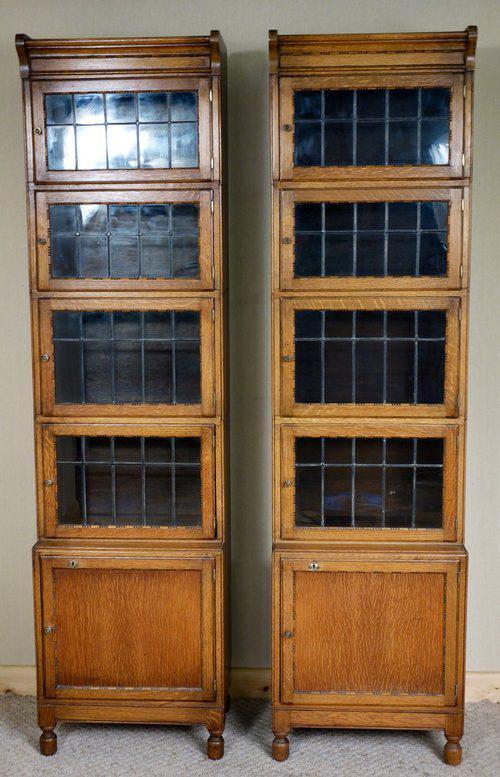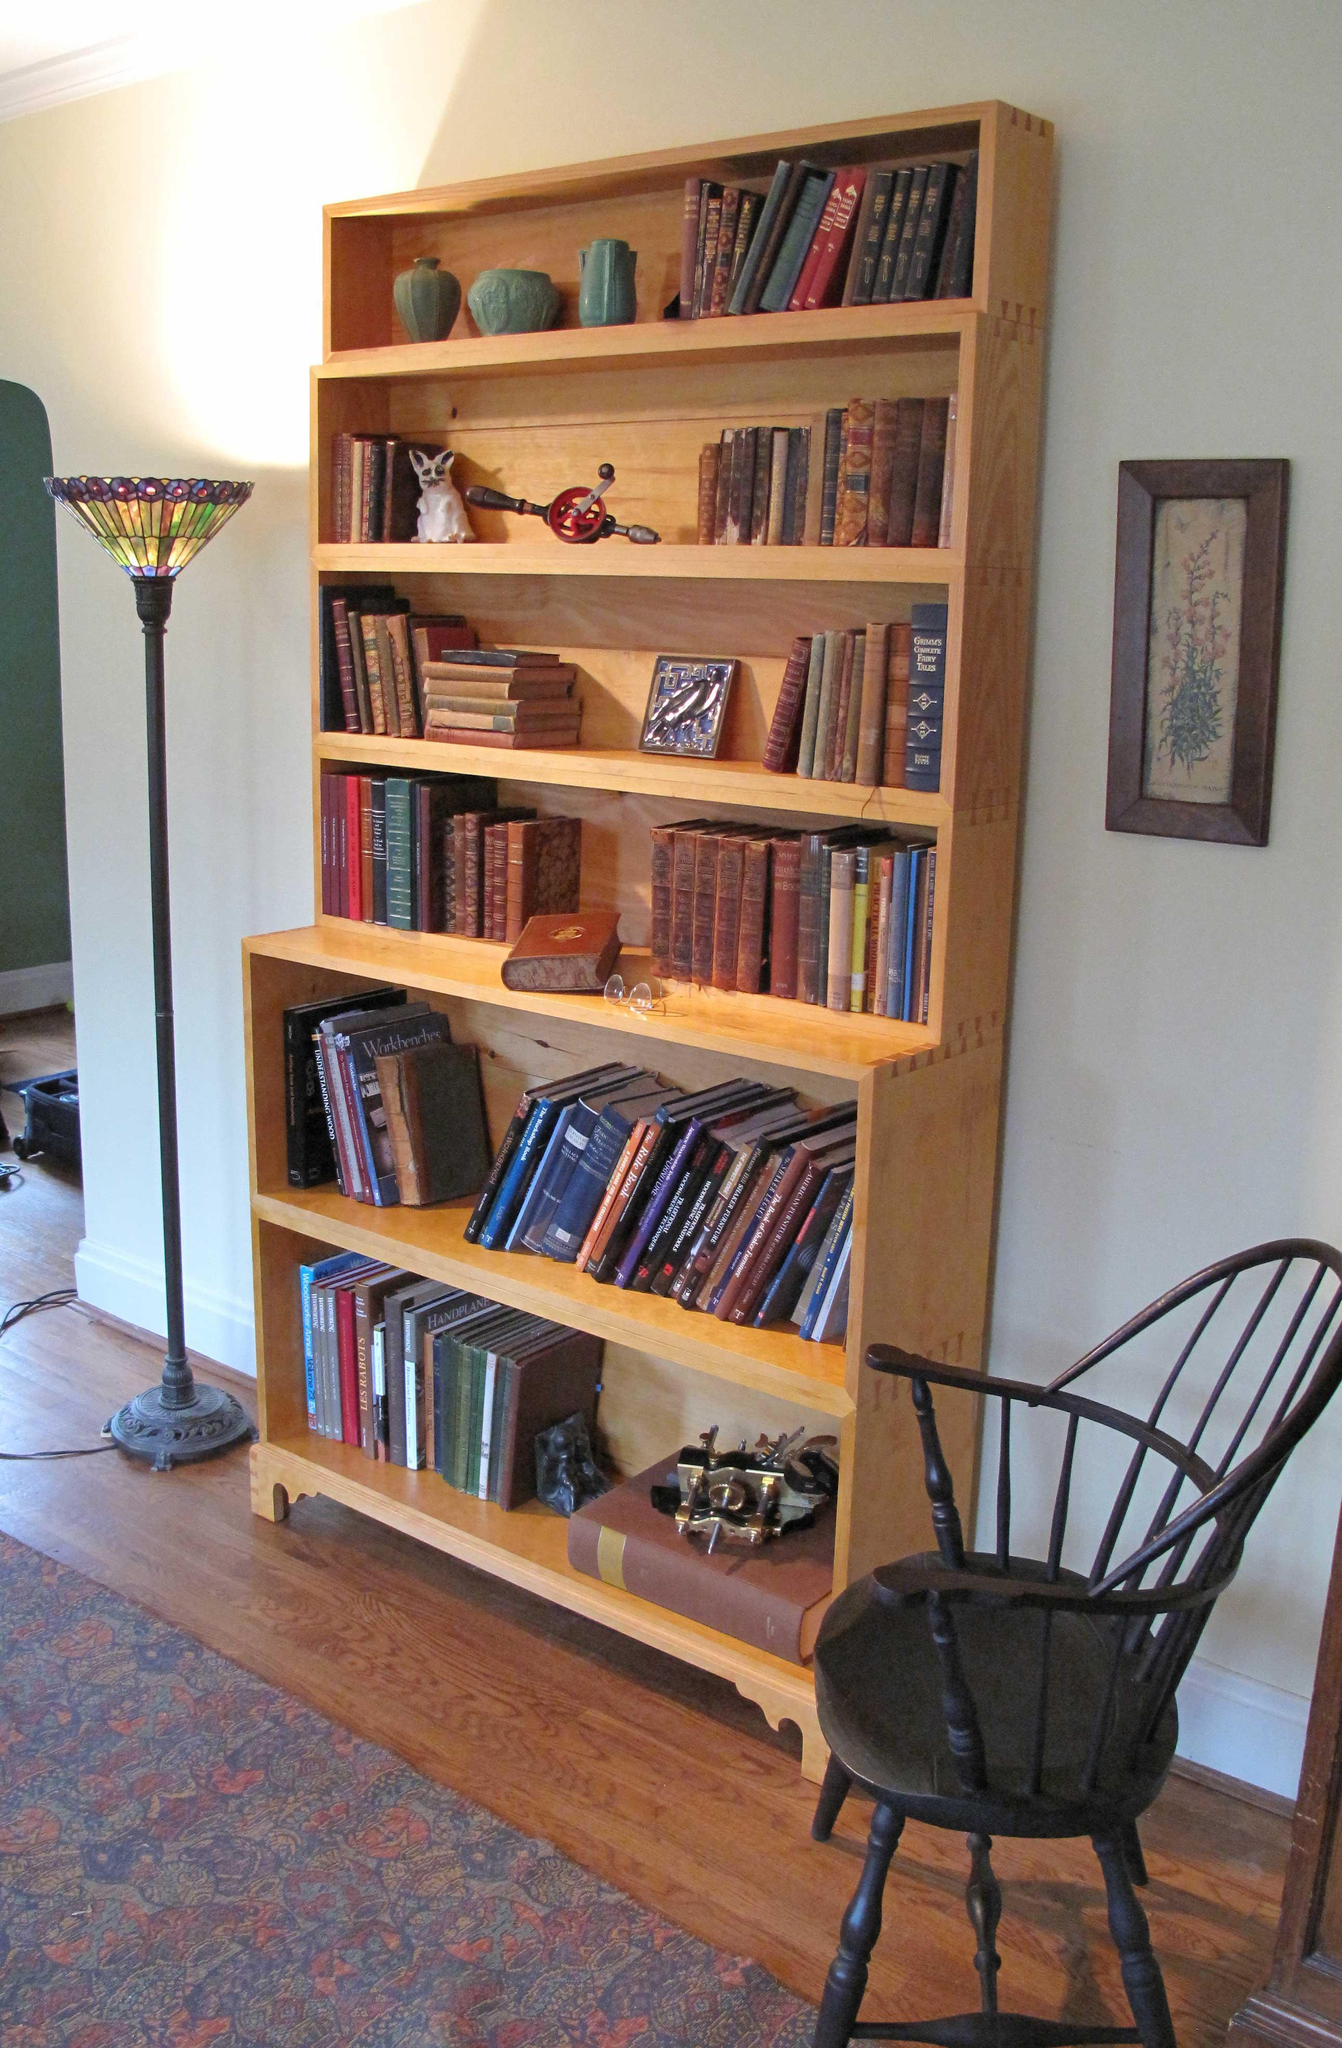The first image is the image on the left, the second image is the image on the right. Examine the images to the left and right. Is the description "The cabinet in the left image has glass panes." accurate? Answer yes or no. Yes. The first image is the image on the left, the second image is the image on the right. Analyze the images presented: Is the assertion "One of the images includes a bookcase with glass on the front." valid? Answer yes or no. Yes. 